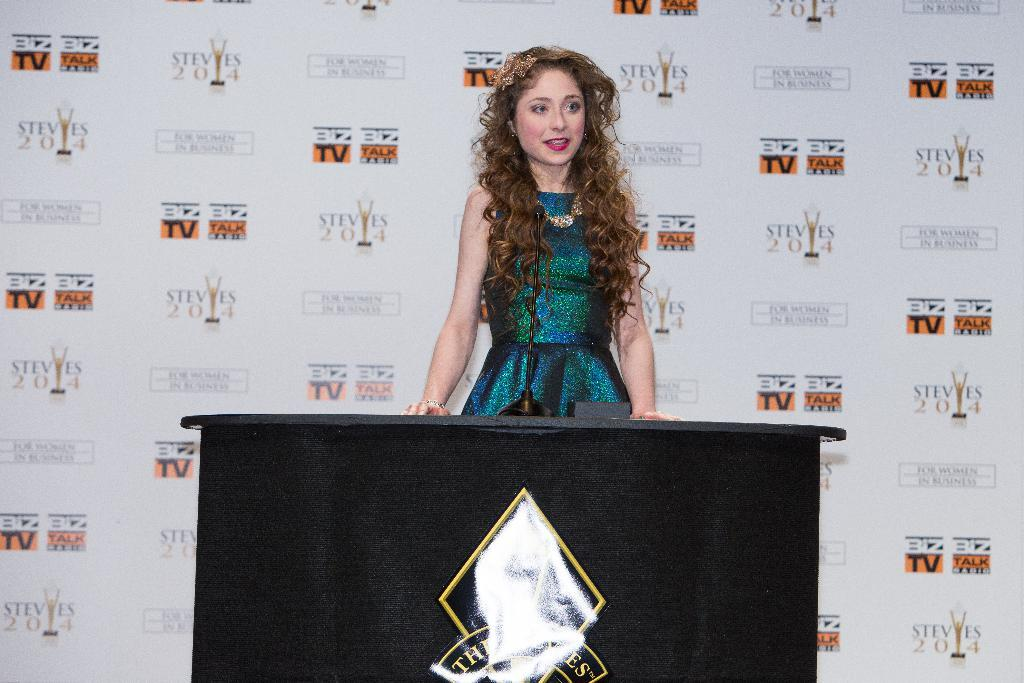Who is present in the image? There is a woman in the image. What is the woman standing near? There is a table in the image. What object can be seen on the table? There is a mic on the table in the image. Can you describe the object in the image? There is an object in the image, but its specific details are not clear from the provided facts. What can be seen in the background of the image? There is a banner in the background of the image. What type of machine can be seen in the cave in the image? There is no machine or cave present in the image. 